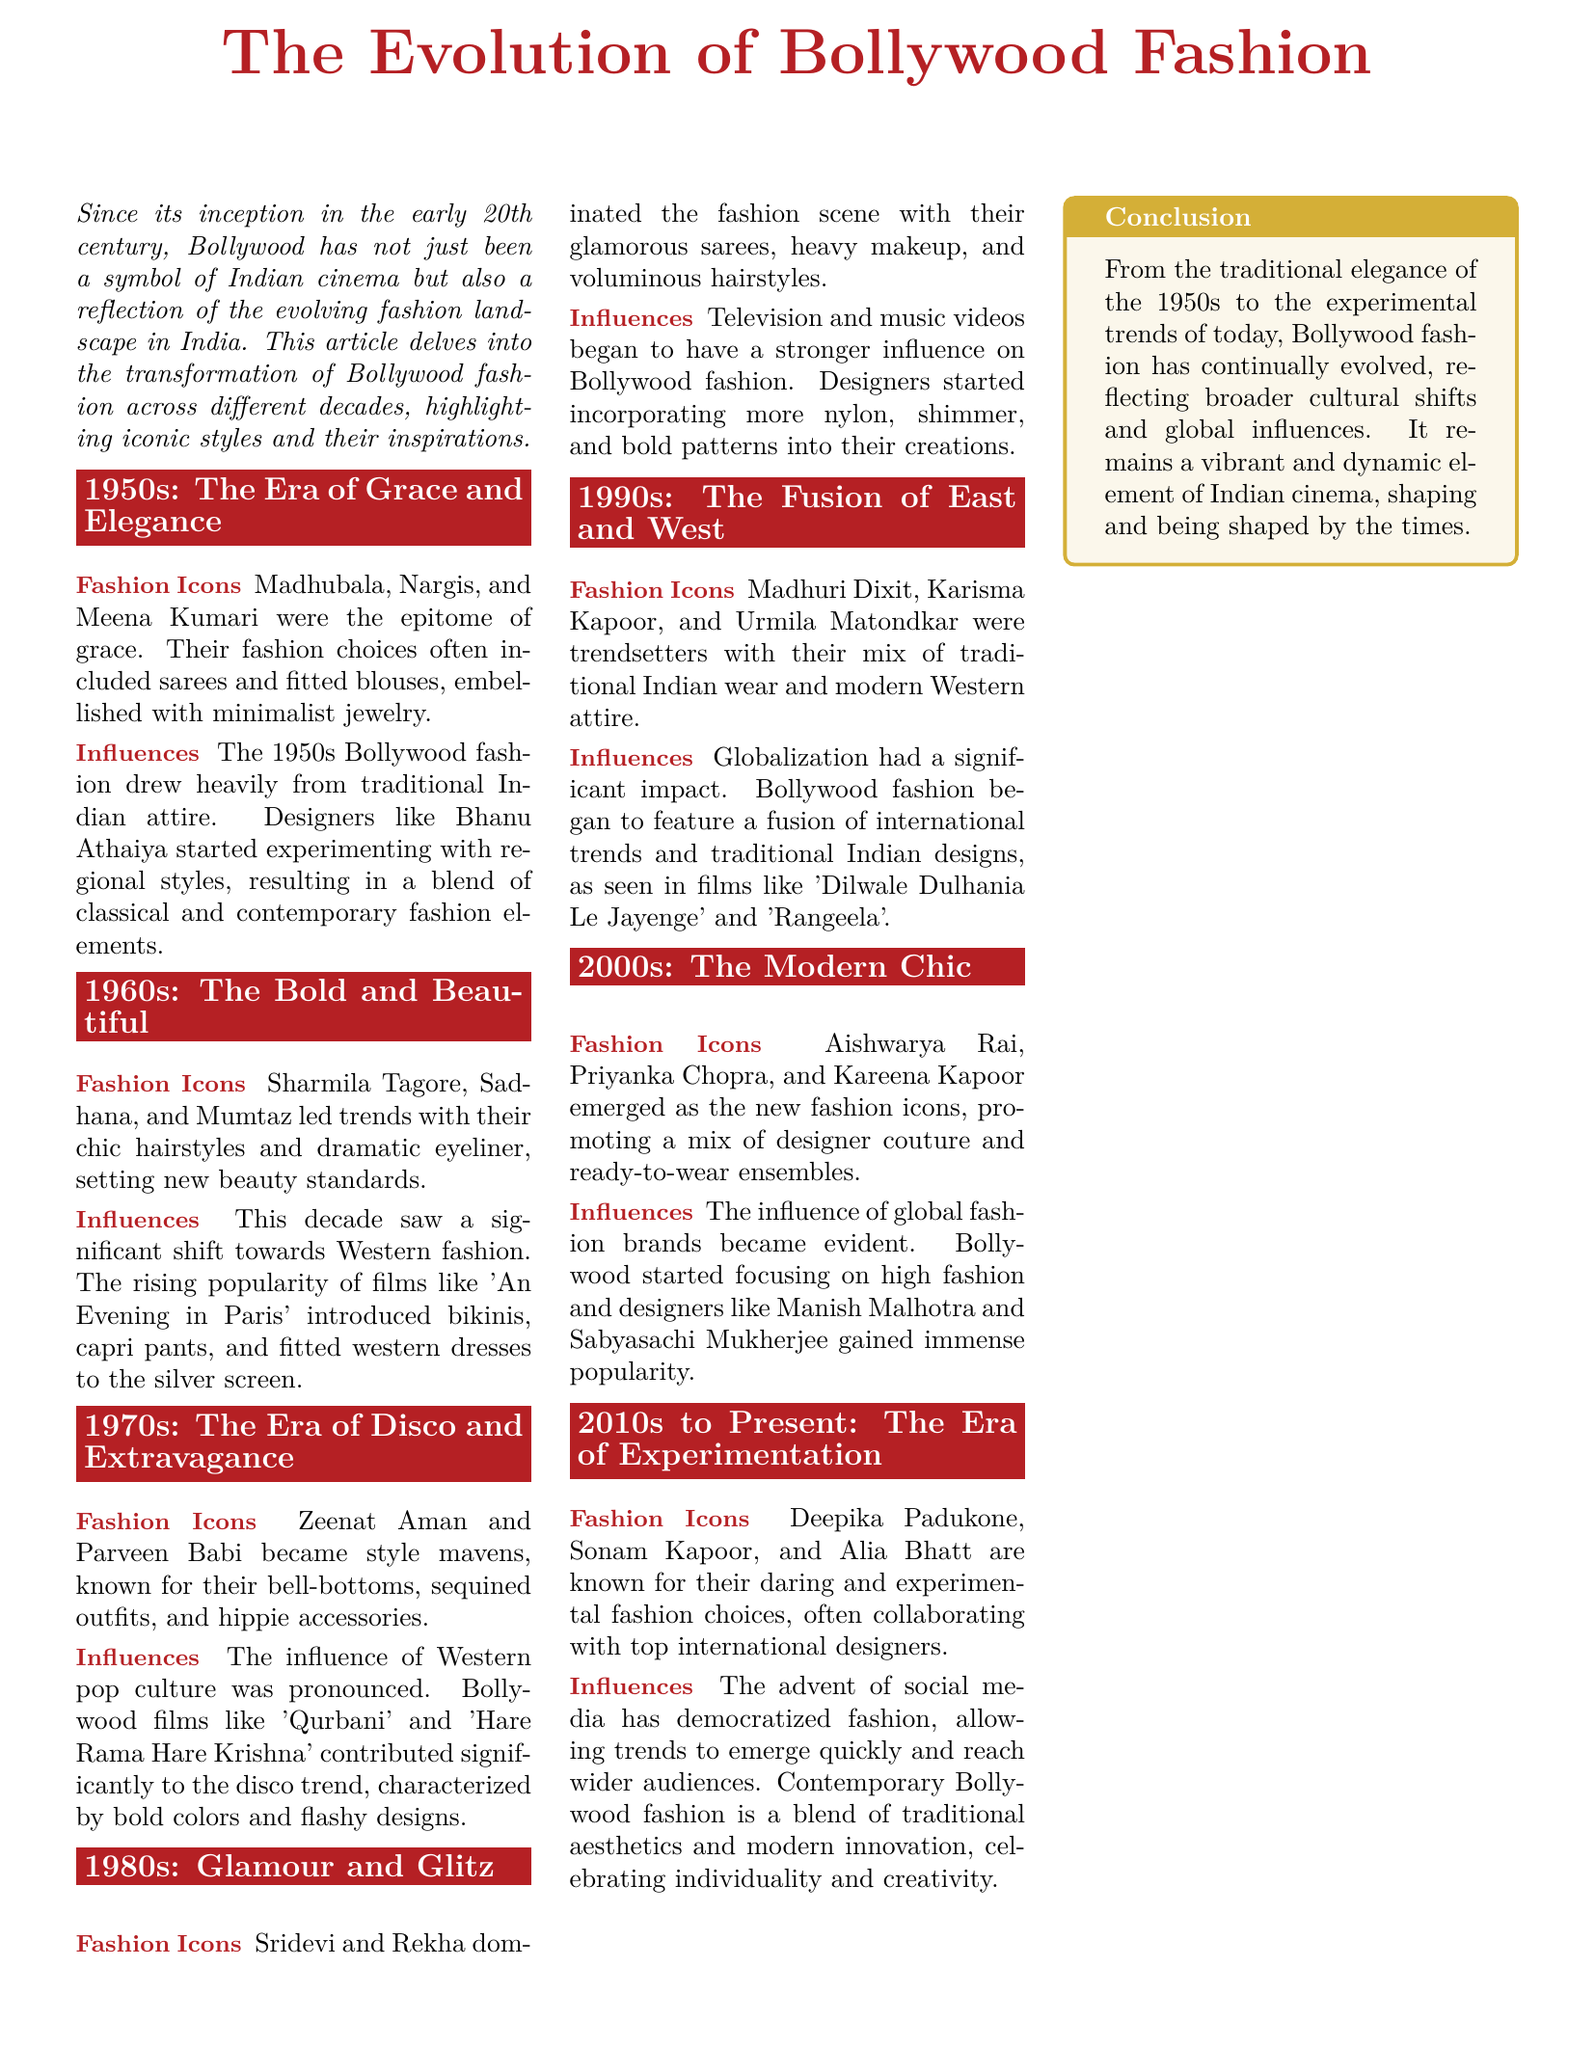What decade is characterized by grace and elegance? The 1950s is highlighted as the decade representing grace and elegance in Bollywood fashion.
Answer: 1950s Who were the fashion icons of the 1970s? The document lists Zeenat Aman and Parveen Babi as fashion icons of the 1970s due to their distinct style choices.
Answer: Zeenat Aman and Parveen Babi Which international trend influenced Bollywood fashion in the 1990s? The fusion of international trends and traditional Indian designs significantly influenced Bollywood fashion during the 1990s.
Answer: Globalization What fashion styles emerged in the 2000s? The document mentions a mix of designer couture and ready-to-wear ensembles as key styles in the 2000s Bollywood fashion.
Answer: Designer couture and ready-to-wear What major cultural shift is reflected in the fashion of the 2010s? The document states that social media has democratized fashion, allowing for quick trends to emerge.
Answer: Social media Which film inspired Western fashion elements in the 1960s? The film 'An Evening in Paris' is noted for introducing Western fashion elements such as bikinis and capri pants.
Answer: An Evening in Paris What material became prominent in the fashion of the 1980s? The document highlights that designers started using more nylon and shimmer in their creations during the 1980s.
Answer: Nylon What is the overall conclusion about Bollywood fashion evolution? The conclusion states that Bollywood fashion has evolved continually, reflecting cultural shifts and global influences.
Answer: Evolved continually Who is a prominent fashion icon mentioned for the 2000s? Aishwarya Rai is introduced as one of the new fashion icons for the 2000s.
Answer: Aishwarya Rai 